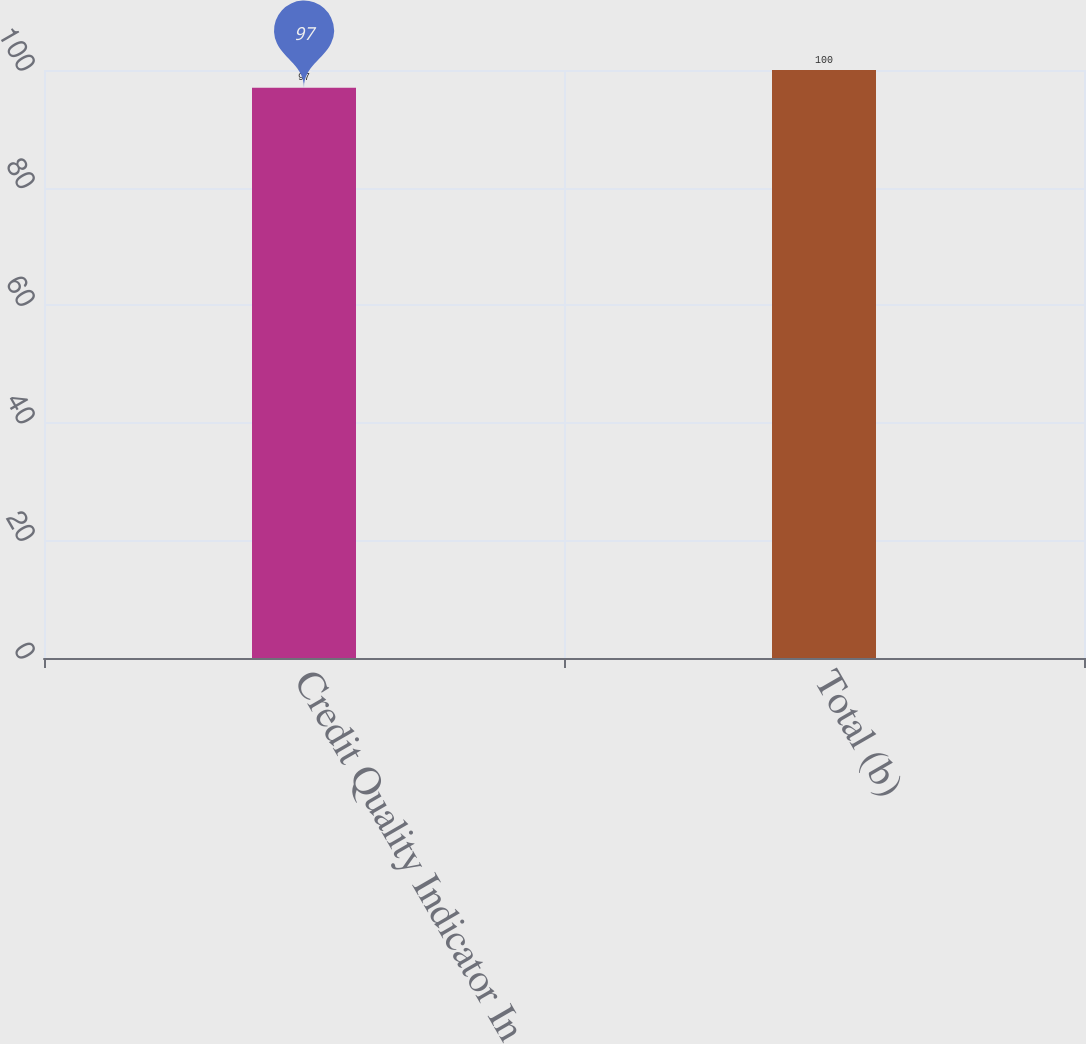Convert chart. <chart><loc_0><loc_0><loc_500><loc_500><bar_chart><fcel>Credit Quality Indicator In<fcel>Total (b)<nl><fcel>97<fcel>100<nl></chart> 